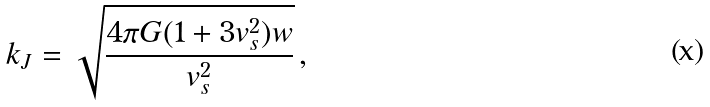Convert formula to latex. <formula><loc_0><loc_0><loc_500><loc_500>k _ { J } = \sqrt { \frac { 4 \pi G ( 1 + 3 v _ { s } ^ { 2 } ) w } { v _ { s } ^ { 2 } } } \, ,</formula> 